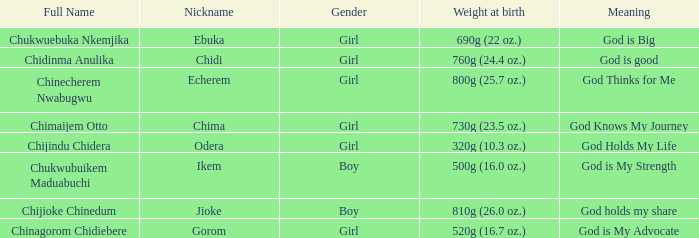0 oz.) at birth? Jioke. 